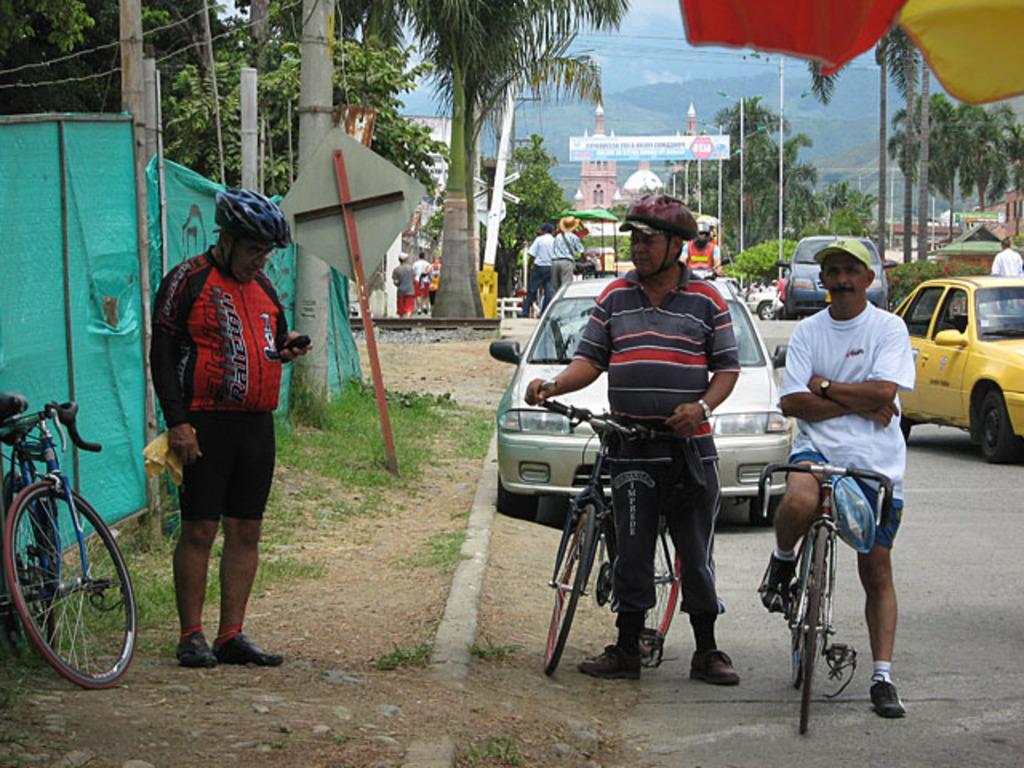Could you give a brief overview of what you see in this image? In this picture we can see three persons. These are the bicycles. There are cars on the road. These are the trees and there is a pole. 